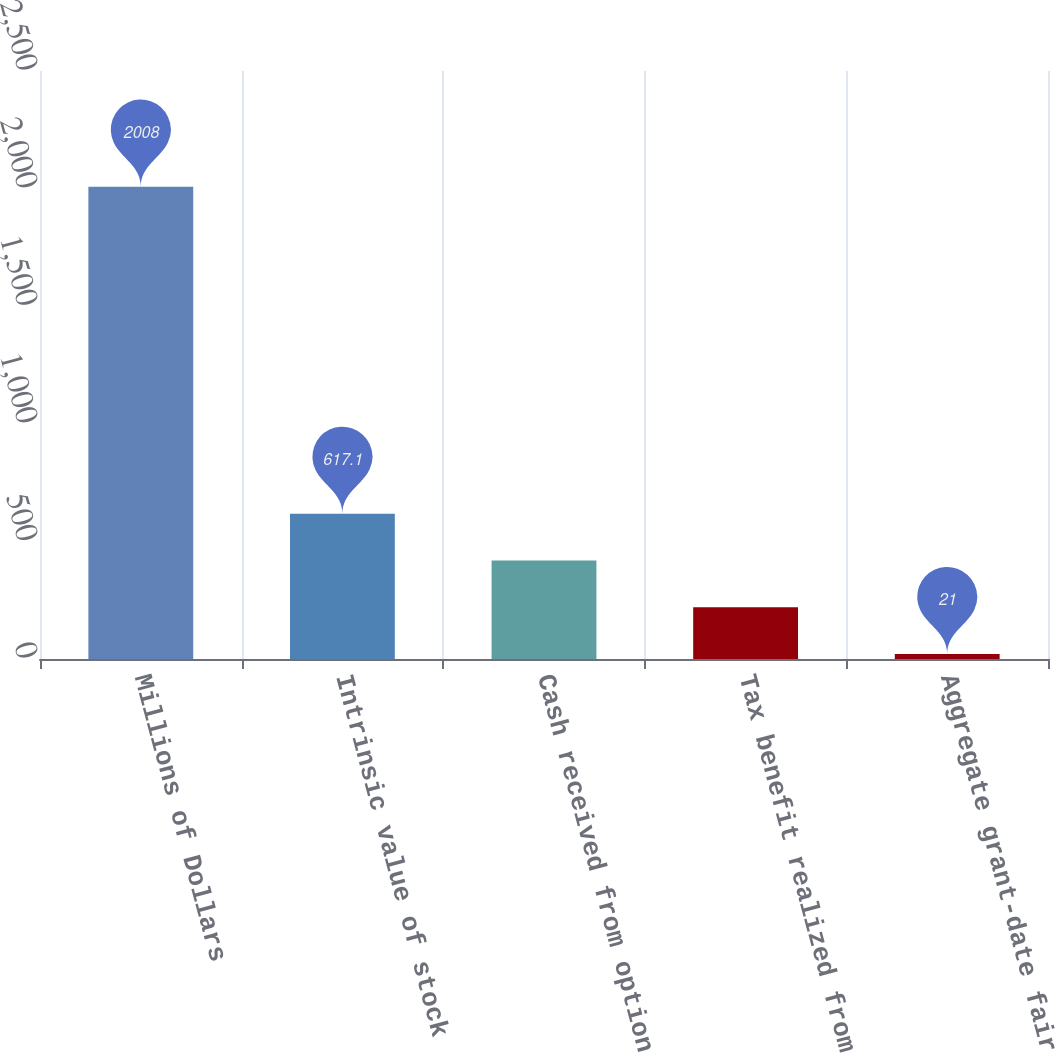Convert chart. <chart><loc_0><loc_0><loc_500><loc_500><bar_chart><fcel>Millions of Dollars<fcel>Intrinsic value of stock<fcel>Cash received from option<fcel>Tax benefit realized from<fcel>Aggregate grant-date fair<nl><fcel>2008<fcel>617.1<fcel>418.4<fcel>219.7<fcel>21<nl></chart> 